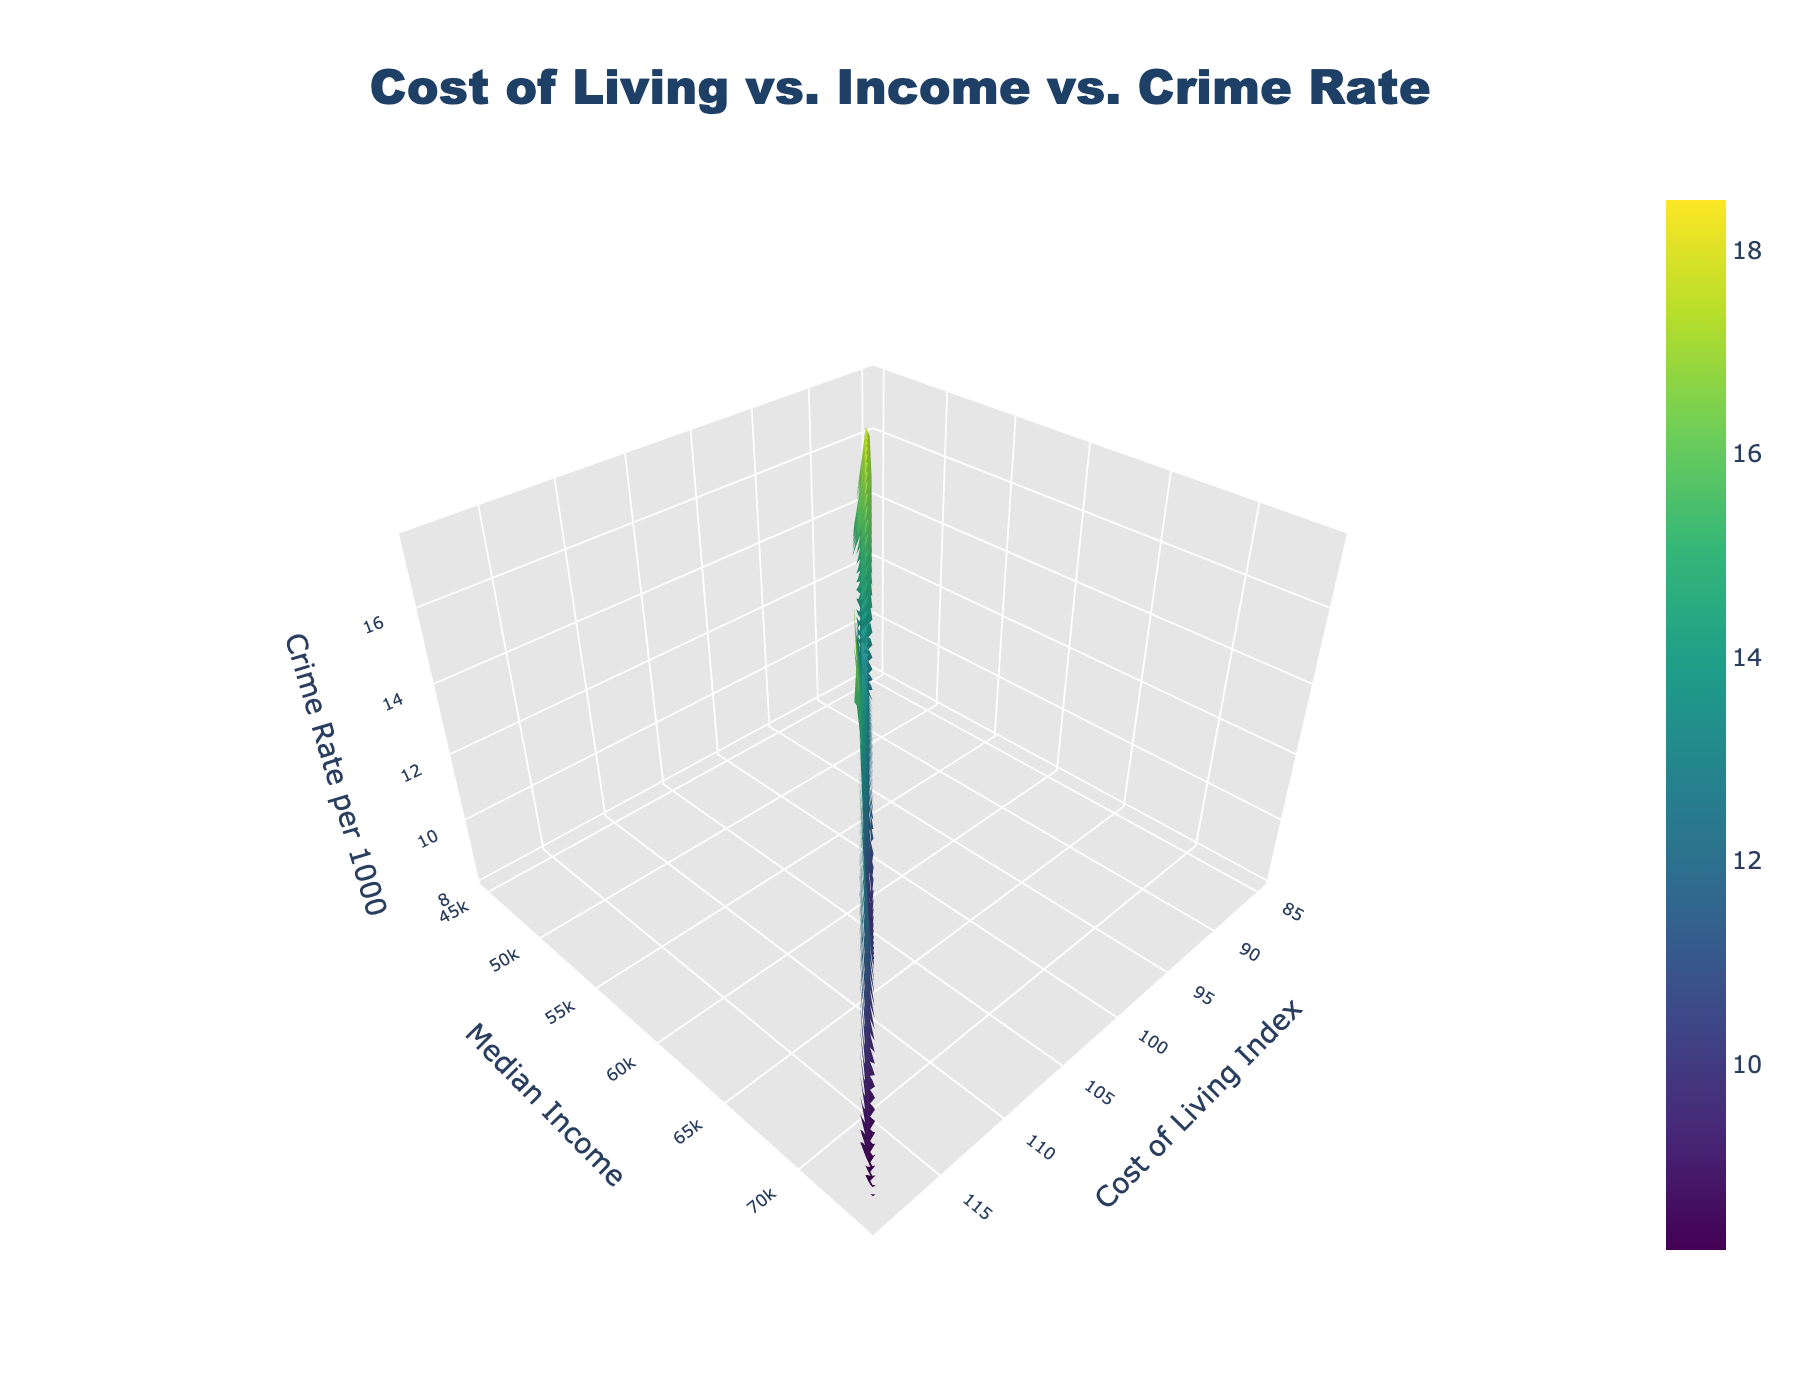What is the title of the plot? The title is usually displayed at the top of the figure and aims to summarize the content of the plot succinctly.
Answer: Cost of Living vs. Income vs. Crime Rate What does the color scale represent in this plot? The color scale in a surface plot is used to represent different values of the variable shown on the Z-axis, which in this case is the Crime Rate per 1000.
Answer: Crime Rate per 1000 Which neighborhood might have the highest crime rate based on the plot? By looking at the peak areas on the surface plot and matching them with the color scale, you can find the locations indicating the highest crime rates.
Answer: Downtown Is there a general trend between Cost of Living Index and Crime Rate when Median Income is held constant? Examine the surface plot by following lines parallel to the Cost of Living Index axis while keeping the Median Income constant. Look for upward or downward trends in the crime rate values.
Answer: Higher Cost of Living Index generally correlates with higher Crime Rates How does the Crime Rate change as Median Income increases while keeping the Cost of Living Index constant? Follow lines parallel to the Median Income axis on the surface plot while keeping the Cost of Living Index constant. Observe whether the crime rate increases, decreases, or remains the same.
Answer: Crime Rate tends to decrease as Median Income increases What is the value range of the Median Income axis? Examine the Y-axis (Median Income) range values on the plot to determine the minimum and maximum values it covers.
Answer: $45,000 to $75,000 Compare the Median Income level and Crime Rate between Oak Hills and Riverside. Identify the coordinates for Oak Hills and Riverside on the plot, and compare the median income values and corresponding crime rates for both neighborhoods.
Answer: Oak Hills has a higher Median Income ($75,000) and lower Crime Rate (8.2) than Riverside ($52,000 and 14.7) Which neighborhood likely has the lowest Crime Rate according to the surface plot? Look for the lowest points on the surface plot and match these areas to the corresponding neighborhoods using the provided data.
Answer: Oak Hills What is the average Crime Rate across all neighborhoods shown? Sum all the crime rates from the provided data and divide by the number of neighborhoods to get the average.
Answer: 12.49 As both Cost of Living Index and Median Income increase, what general trend can be observed in Crime Rates? By observing the overall landscape of the surface plot and noting how the Z-values (Crime Rates) change, one can deduce a general trend.
Answer: Crime Rates tend to decrease or stabilize with increasing Cost of Living Index and Median Income 